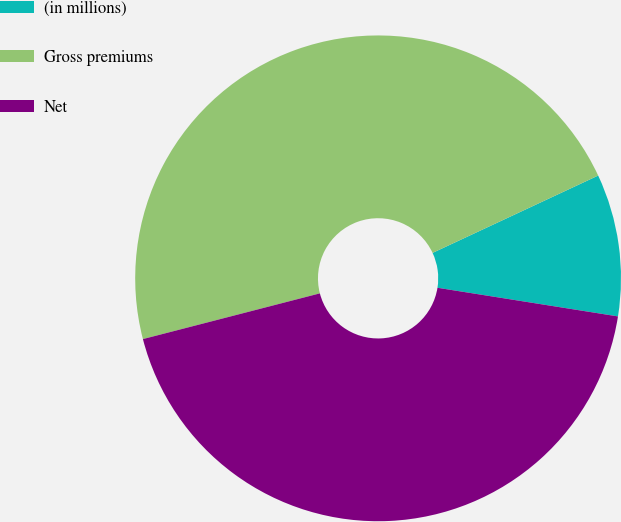Convert chart to OTSL. <chart><loc_0><loc_0><loc_500><loc_500><pie_chart><fcel>(in millions)<fcel>Gross premiums<fcel>Net<nl><fcel>9.46%<fcel>47.07%<fcel>43.47%<nl></chart> 